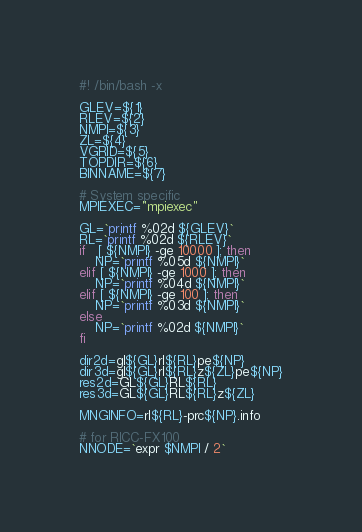Convert code to text. <code><loc_0><loc_0><loc_500><loc_500><_Bash_>#! /bin/bash -x

GLEV=${1}
RLEV=${2}
NMPI=${3}
ZL=${4}
VGRID=${5}
TOPDIR=${6}
BINNAME=${7}

# System specific
MPIEXEC="mpiexec"

GL=`printf %02d ${GLEV}`
RL=`printf %02d ${RLEV}`
if   [ ${NMPI} -ge 10000 ]; then
	NP=`printf %05d ${NMPI}`
elif [ ${NMPI} -ge 1000 ]; then
	NP=`printf %04d ${NMPI}`
elif [ ${NMPI} -ge 100 ]; then
	NP=`printf %03d ${NMPI}`
else
	NP=`printf %02d ${NMPI}`
fi

dir2d=gl${GL}rl${RL}pe${NP}
dir3d=gl${GL}rl${RL}z${ZL}pe${NP}
res2d=GL${GL}RL${RL}
res3d=GL${GL}RL${RL}z${ZL}

MNGINFO=rl${RL}-prc${NP}.info

# for RICC-FX100
NNODE=`expr $NMPI / 2`
</code> 